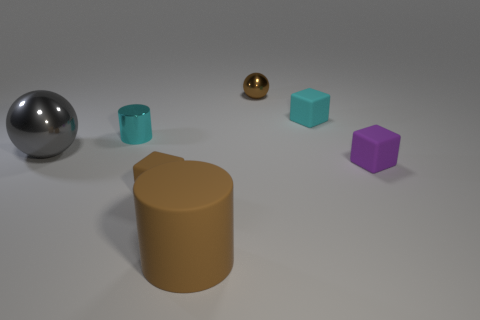Is the material of the small brown sphere the same as the cylinder in front of the gray metal thing?
Ensure brevity in your answer.  No. Is the number of purple things that are behind the cyan rubber thing greater than the number of tiny cyan shiny cylinders?
Your response must be concise. No. The matte thing that is the same color as the matte cylinder is what shape?
Your response must be concise. Cube. Is there a big yellow ball made of the same material as the brown cylinder?
Ensure brevity in your answer.  No. Is the brown object behind the small cyan metal cylinder made of the same material as the big thing behind the purple matte block?
Provide a succinct answer. Yes. Is the number of rubber cubes that are behind the brown shiny ball the same as the number of small shiny things right of the brown matte cube?
Your answer should be compact. No. There is a shiny sphere that is the same size as the cyan rubber thing; what is its color?
Keep it short and to the point. Brown. Is there a tiny matte block of the same color as the large rubber thing?
Your answer should be compact. Yes. How many things are small blocks that are on the right side of the small brown sphere or tiny cyan matte objects?
Make the answer very short. 2. What number of other things are there of the same size as the brown metal object?
Provide a short and direct response. 4. 